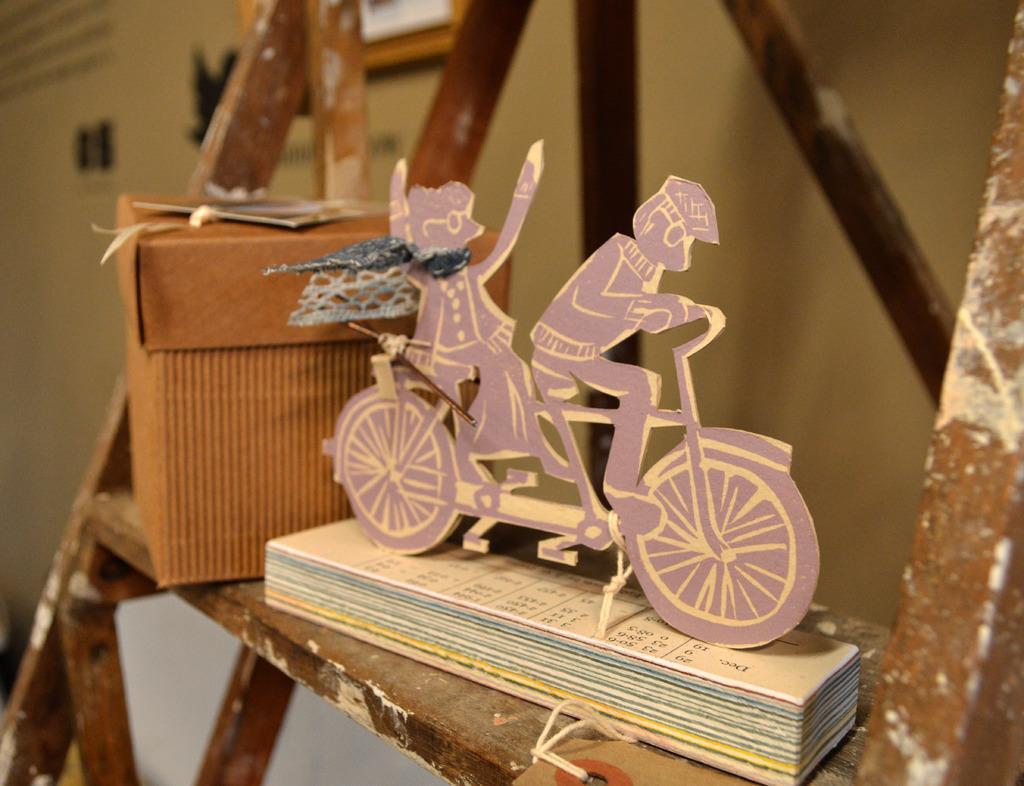How would you summarize this image in a sentence or two? In this picture there is a toy which is kept on this book. Beside that I can see the brown color box which is kept on this wooden ladder. In the back I can see the door, photo frames and wall. 